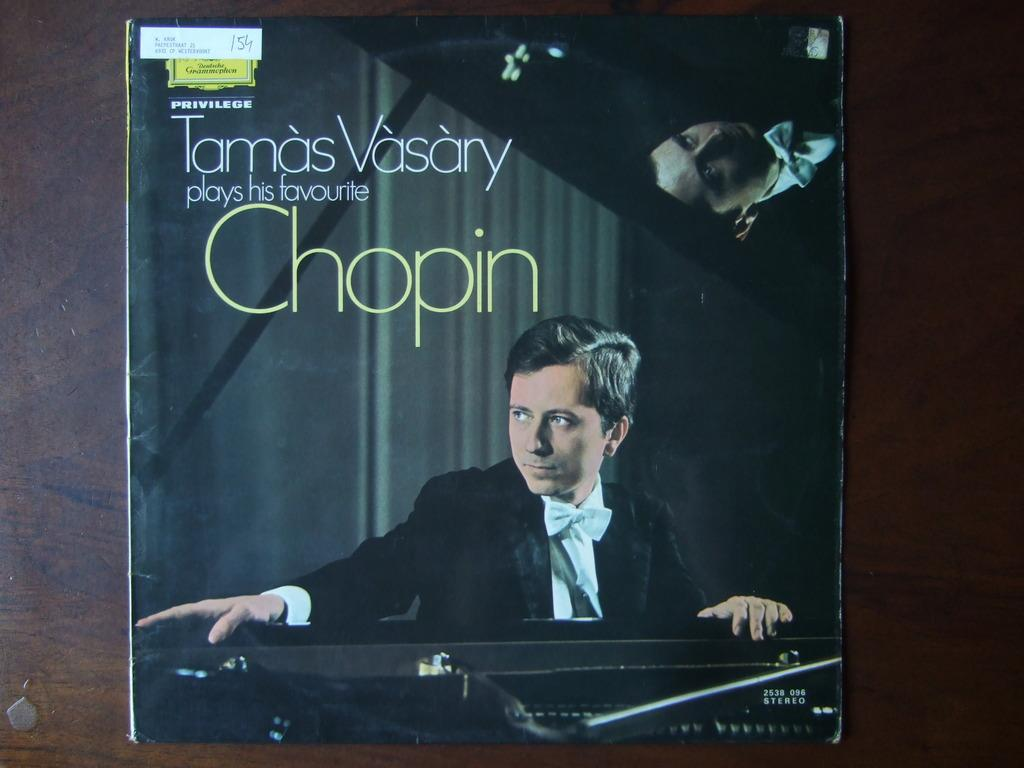What is the main subject of the poster in the image? The poster features a person wearing a black coat. What else can be seen on the poster besides the person? There is text present on the poster. Reasoning: Let'g: Let's think step by step in order to produce the conversation. We start by identifying the main subject of the poster, which is the person wearing a black coat. Then, we expand the conversation to include other elements present on the poster, such as the text. Each question is designed to elicit a specific detail about the image that is known from the provided facts. Absurd Question/Answer: Where is the faucet located in the image? There is no faucet present in the image. In which direction is the person on the poster facing, north or south? The direction the person is facing cannot be determined from the image, as there is no reference point for north or south. How many knots are tied in the person's coat on the poster? There are no visible knots in the person's coat on the poster. What type of fabric is the person's coat made of, as seen in the image? The type of fabric cannot be determined from the image, as the focus is on the color (black) rather than the material. 